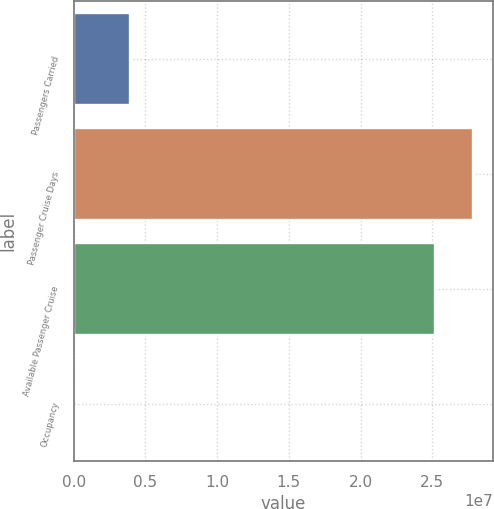Convert chart. <chart><loc_0><loc_0><loc_500><loc_500><bar_chart><fcel>Passengers Carried<fcel>Passenger Cruise Days<fcel>Available Passenger Cruise<fcel>Occupancy<nl><fcel>3.90538e+06<fcel>2.78152e+07<fcel>2.51558e+07<fcel>105.7<nl></chart> 